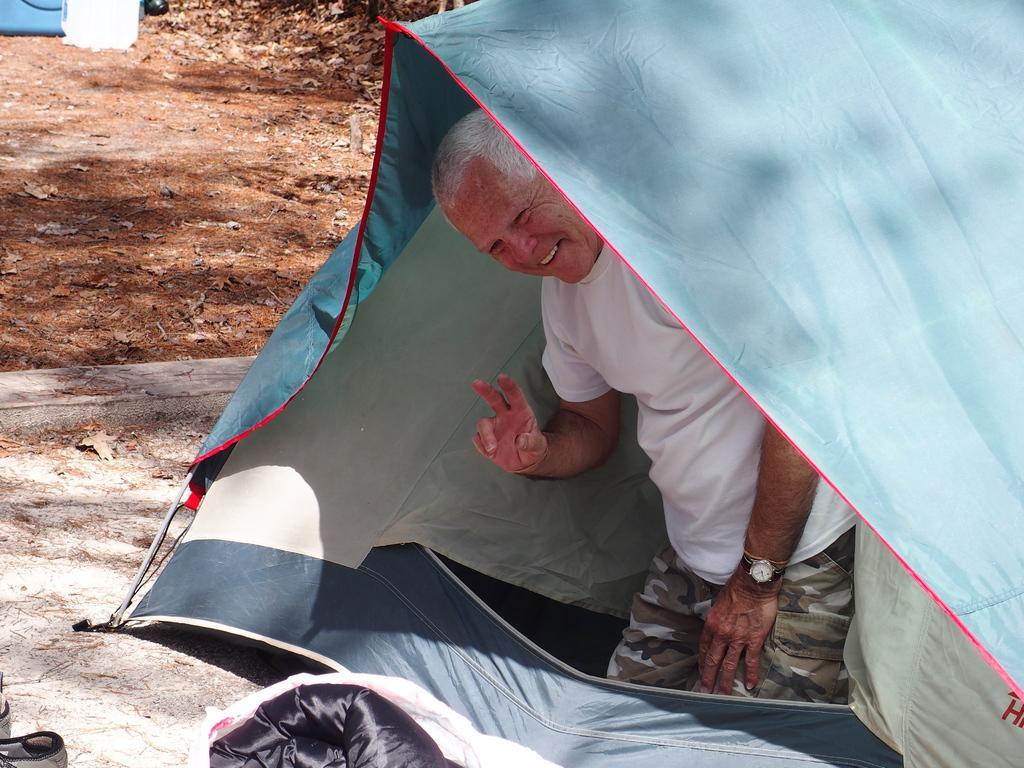Please provide a concise description of this image. In this image inside a tent there is an old man wearing white t-shirt. He is smiling. In the background on the ground there are dried leaves. 